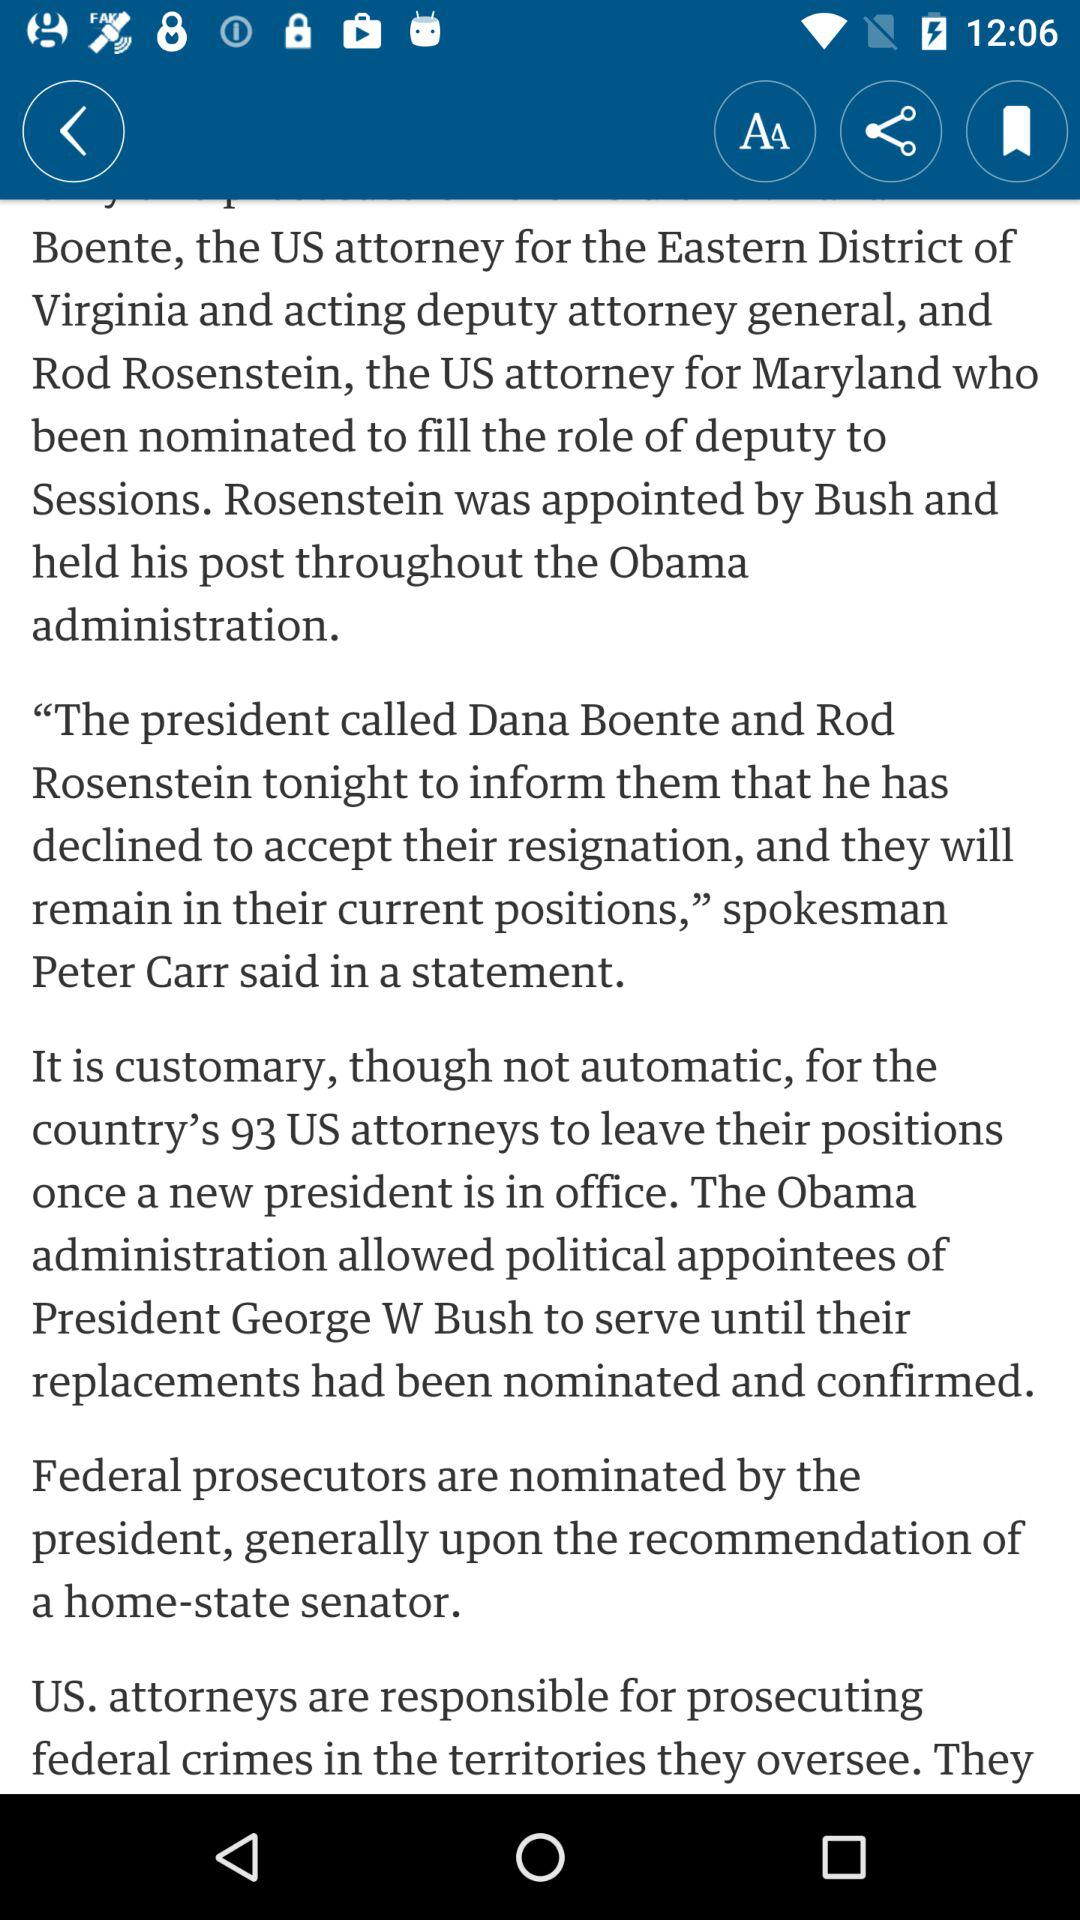Who is the spokesman who issued the statement? The spokesman is Peter Carr. 